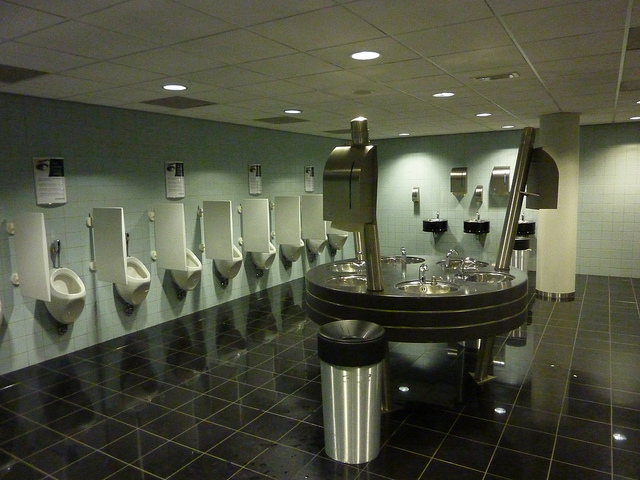<image>What brand of sink is this? I am not sure what the brand of the sink is. It could be 'kohler', 'whirlpool' or 'moen'. What brand of sink is this? I don't know what brand of sink it is. It can be Kohler, Whirlpool, Moen, or any other brand. 